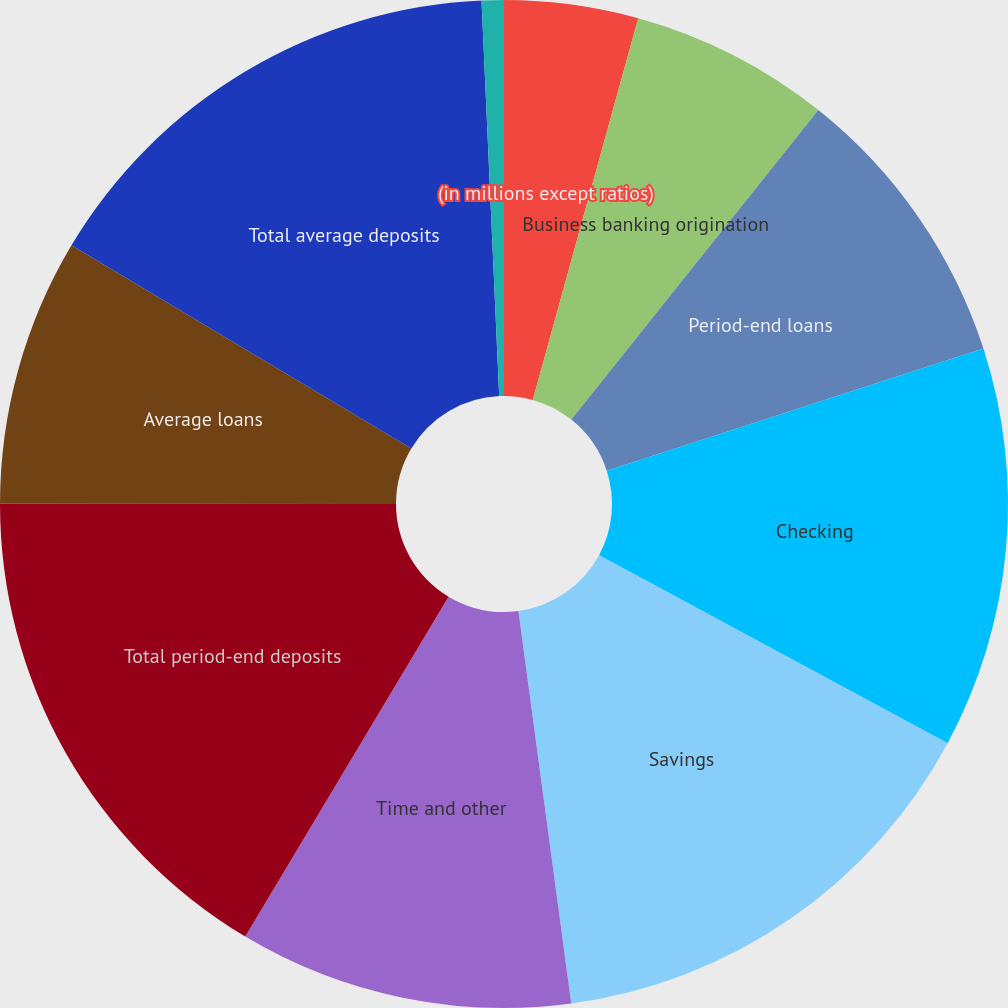Convert chart. <chart><loc_0><loc_0><loc_500><loc_500><pie_chart><fcel>(in millions except ratios)<fcel>Business banking origination<fcel>Period-end loans<fcel>Checking<fcel>Savings<fcel>Time and other<fcel>Total period-end deposits<fcel>Average loans<fcel>Total average deposits<fcel>Deposit margin<nl><fcel>4.29%<fcel>6.43%<fcel>9.29%<fcel>12.86%<fcel>15.0%<fcel>10.71%<fcel>16.43%<fcel>8.57%<fcel>15.71%<fcel>0.71%<nl></chart> 